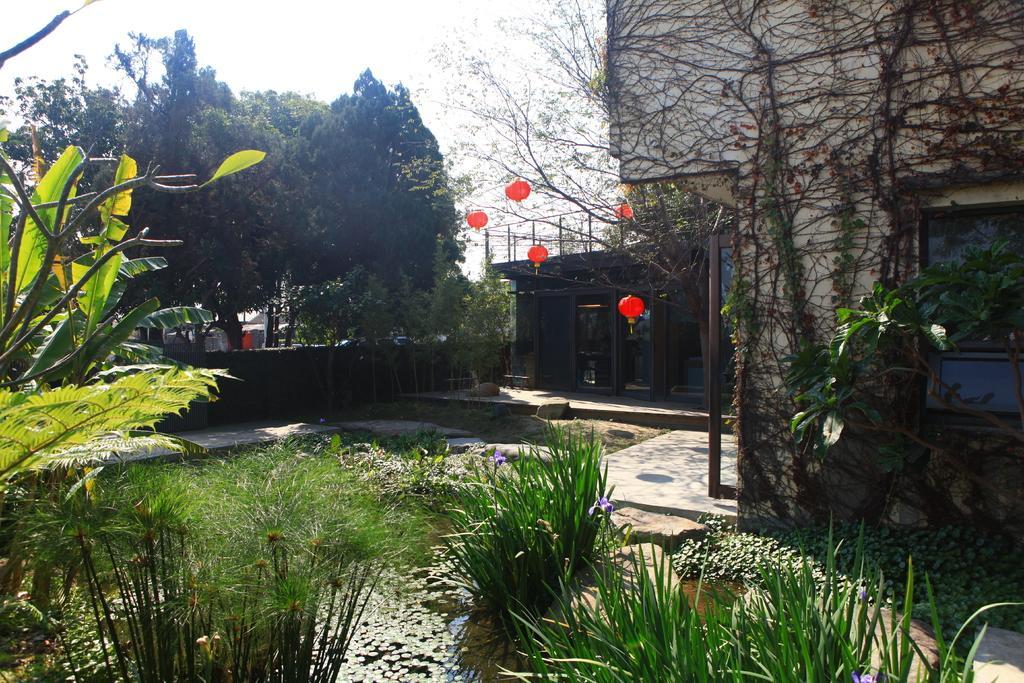How would you summarize this image in a sentence or two? At the bottom of this image, there are plants. Behind these plants, there are plants in the water. In the background, there are buildings, trees, a wall, orange color balloons and there are clouds in the sky. 